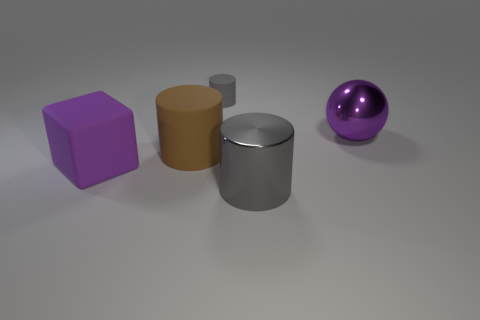There is a cylinder that is behind the metal ball; what color is it?
Make the answer very short. Gray. There is a purple ball to the right of the gray rubber object; are there any rubber cylinders that are behind it?
Offer a very short reply. Yes. There is a big cylinder that is on the left side of the large gray cylinder; is it the same color as the big cylinder that is right of the gray matte cylinder?
Offer a very short reply. No. How many purple things are to the left of the metallic cylinder?
Ensure brevity in your answer.  1. What number of big shiny cylinders are the same color as the metal sphere?
Make the answer very short. 0. Is the cylinder to the left of the small gray rubber object made of the same material as the large ball?
Offer a very short reply. No. What number of big green cylinders have the same material as the brown cylinder?
Keep it short and to the point. 0. Are there more large gray metal cylinders to the left of the brown cylinder than tiny cylinders?
Keep it short and to the point. No. What size is the metallic object that is the same color as the matte cube?
Keep it short and to the point. Large. Is there a large red matte thing of the same shape as the gray metallic object?
Your answer should be very brief. No. 